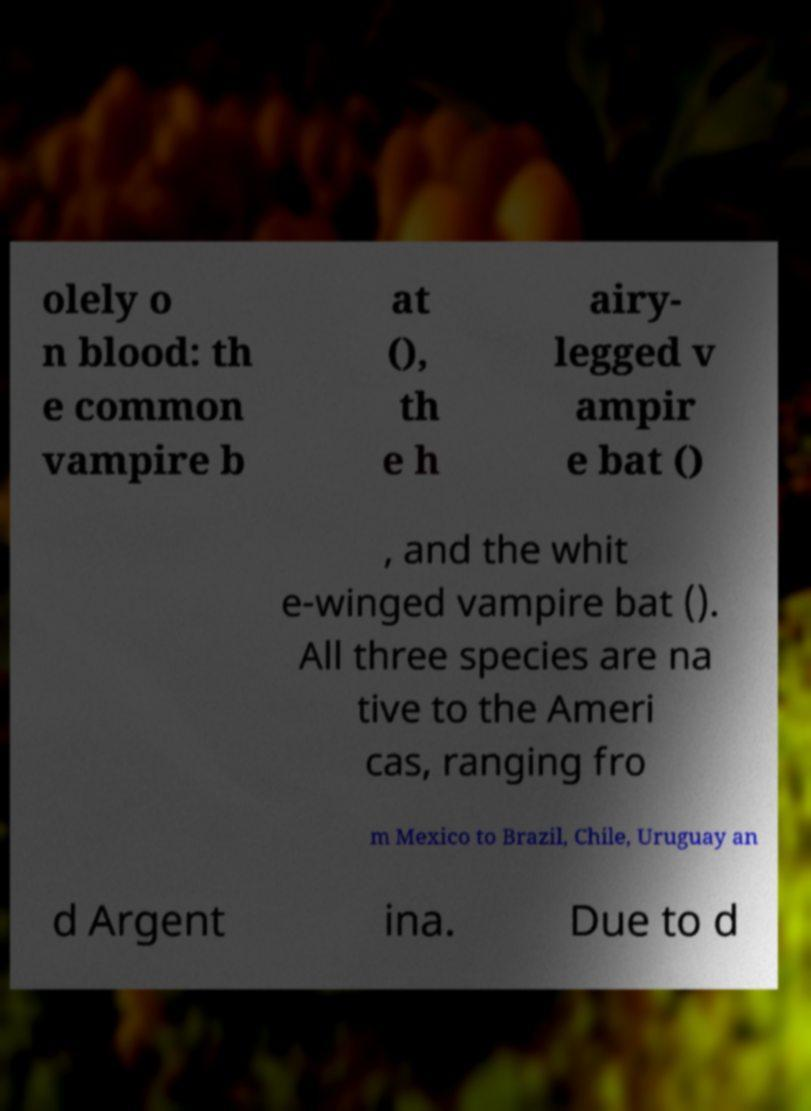I need the written content from this picture converted into text. Can you do that? olely o n blood: th e common vampire b at (), th e h airy- legged v ampir e bat () , and the whit e-winged vampire bat (). All three species are na tive to the Ameri cas, ranging fro m Mexico to Brazil, Chile, Uruguay an d Argent ina. Due to d 